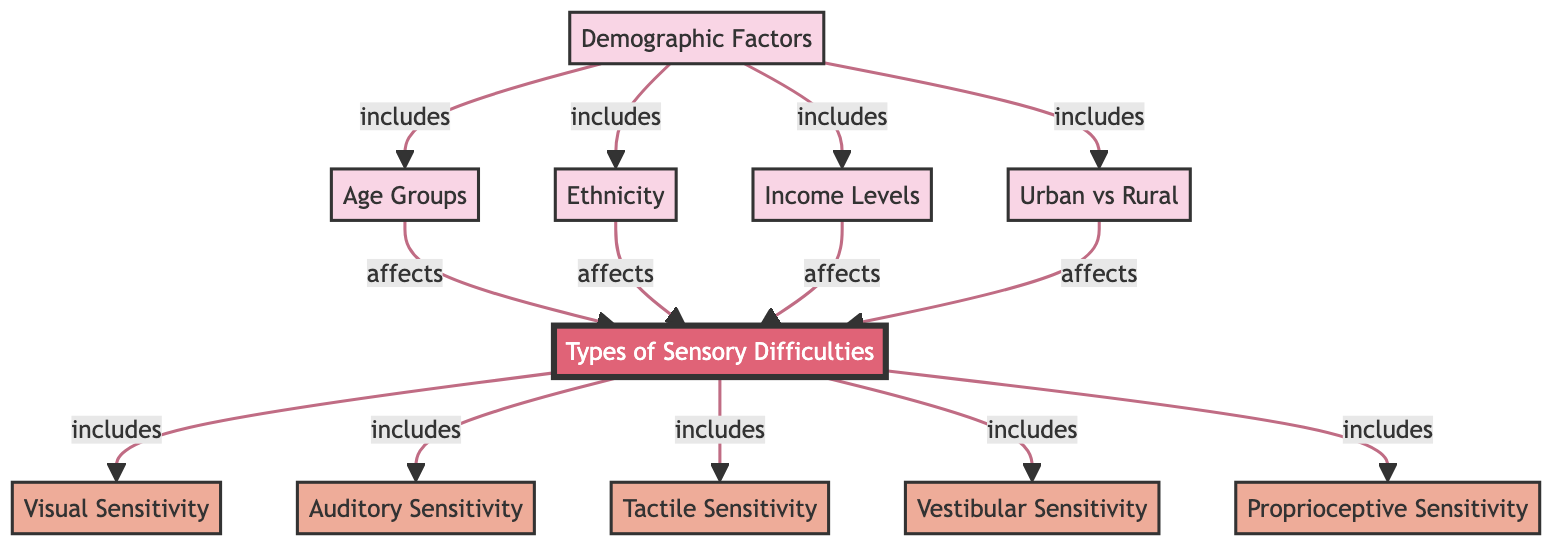What are the main demographic factors explored in the diagram? The diagram lists "Demographic Factors" as the main category, which includes age groups, ethnicity, income levels, and urban vs rural. Each of these is connected to the sensory difficulties indicated in the diagram.
Answer: Age Groups, Ethnicity, Income Levels, Urban vs Rural How many types of sensory difficulties are included in the study? The diagram shows the branch labeled "Types of Sensory Difficulties," which lists five specific types: visual sensitivity, auditory sensitivity, tactile sensitivity, vestibular sensitivity, and proprioceptive sensitivity. This indicates there are a total of five sensory difficulty types being evaluated.
Answer: Five Which demographic factor directly affects auditory sensitivity? The diagram indicates that auditory sensitivity is under the influence of multiple demographic factors. To find a specific one, we trace back from the auditory sensitivity node to the connected demographic factors node. Therefore, any of the demographic factors listed could impact auditory sensitivity.
Answer: All demographic factors What is the relationship between age groups and sensory difficulties? The diagram illustrates a direct connection from the "Age Groups" node to the "Sensory Difficulties" node, indicating that age groups influence or correlate with the various types of sensory difficulties experienced by children.
Answer: Affects Which sensory difficulty is linked to proprioceptive sensitivity? Looking at the sensory difficulties section of the diagram, we see that proprioceptive sensitivity is one of the types listed. Thus, it indicates that proprioceptive difficulties are among the types of sensory difficulties considered in the study.
Answer: Proprioceptive Sensitivity How many overall connections are there from demographic factors to sensory difficulties? The diagram shows four demographic factors and each is linked to the sensory difficulties. Each demographic factor comprises a single direct connection to the sensory difficulties node. Thus, we can calculate the total as: 4 connections from demographic nodes to one sensory difficulties node.
Answer: Four What color represents the main category in the diagram? In the diagram, the main category "Sensory Difficulties" is colored in a specific manner. The color specification for this node is described as a fill of #e06377 and stroke colored in white. This distinct color identification indicates it is the main focus area of the diagram.
Answer: Pink What type of diagram is illustrated here? The structure of this illustration aligns with the characteristics of a social science diagram, which typically includes relationships between various social factors, their influences, and categories of specialized sections. This recognition helps classify the purpose and information conveyed in the diagram accurately.
Answer: Social Science Diagram 